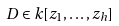<formula> <loc_0><loc_0><loc_500><loc_500>D \in k [ z _ { 1 } , \dots , z _ { h } ]</formula> 